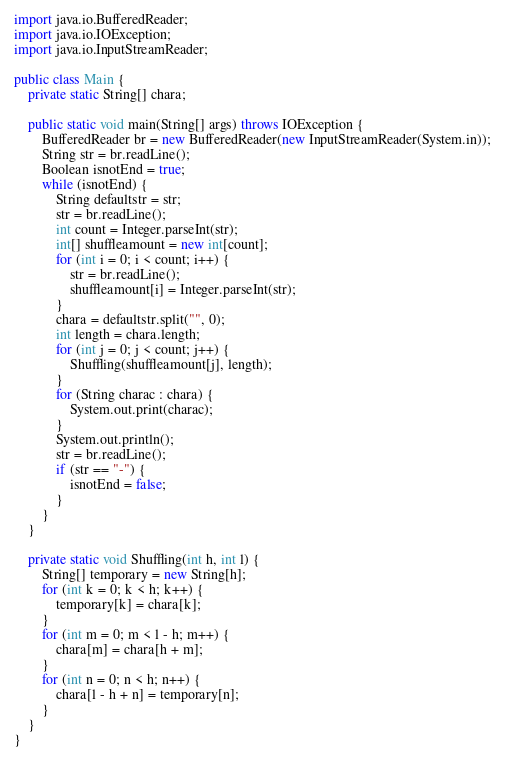<code> <loc_0><loc_0><loc_500><loc_500><_Java_>import java.io.BufferedReader;
import java.io.IOException;
import java.io.InputStreamReader;

public class Main {
	private static String[] chara;

	public static void main(String[] args) throws IOException {
		BufferedReader br = new BufferedReader(new InputStreamReader(System.in));
		String str = br.readLine();
		Boolean isnotEnd = true;
		while (isnotEnd) {
			String defaultstr = str;
			str = br.readLine();
			int count = Integer.parseInt(str);
			int[] shuffleamount = new int[count];
			for (int i = 0; i < count; i++) {
				str = br.readLine();
				shuffleamount[i] = Integer.parseInt(str);
			}
			chara = defaultstr.split("", 0);
			int length = chara.length;
			for (int j = 0; j < count; j++) {
				Shuffling(shuffleamount[j], length);
			}
			for (String charac : chara) {
				System.out.print(charac);
			}
			System.out.println();
			str = br.readLine();
			if (str == "-") {
				isnotEnd = false;
			}
		}
	}

	private static void Shuffling(int h, int l) {
		String[] temporary = new String[h];
		for (int k = 0; k < h; k++) {
			temporary[k] = chara[k];
		}
		for (int m = 0; m < l - h; m++) {
			chara[m] = chara[h + m];
		}
		for (int n = 0; n < h; n++) {
			chara[l - h + n] = temporary[n];
		}
	}
}</code> 